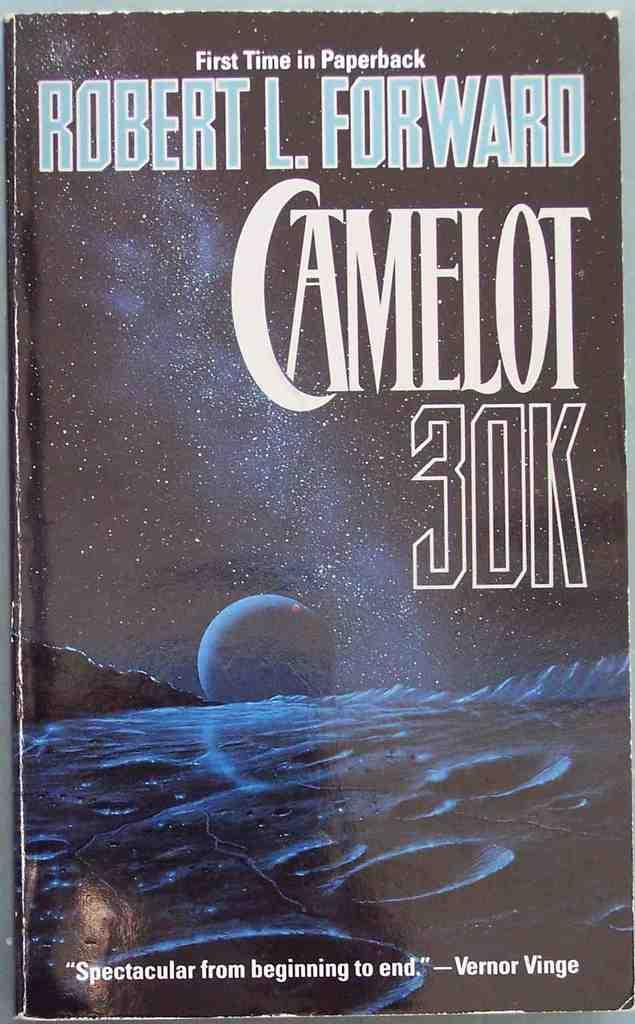<image>
Share a concise interpretation of the image provided. A book by Robert Forward called Camelot 30k. 